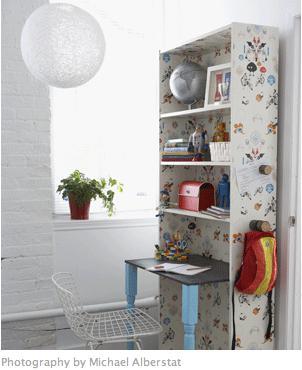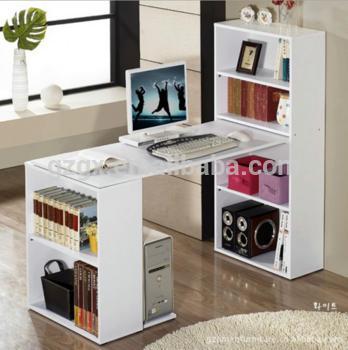The first image is the image on the left, the second image is the image on the right. Assess this claim about the two images: "A window is behind a white desk with a desktop computer on it and a bookshelf component against a wall.". Correct or not? Answer yes or no. Yes. The first image is the image on the left, the second image is the image on the right. Examine the images to the left and right. Is the description "A desk unit in one image is comprised of a bookcase with four shelves at one end and a two-shelf bookcase at the other end, with a desktop extending between them." accurate? Answer yes or no. Yes. 